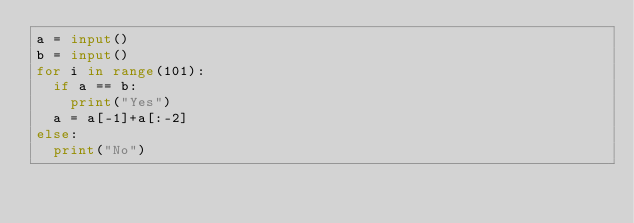Convert code to text. <code><loc_0><loc_0><loc_500><loc_500><_Python_>a = input()
b = input()
for i in range(101):
  if a == b:
    print("Yes")
  a = a[-1]+a[:-2]
else:
  print("No")
  </code> 